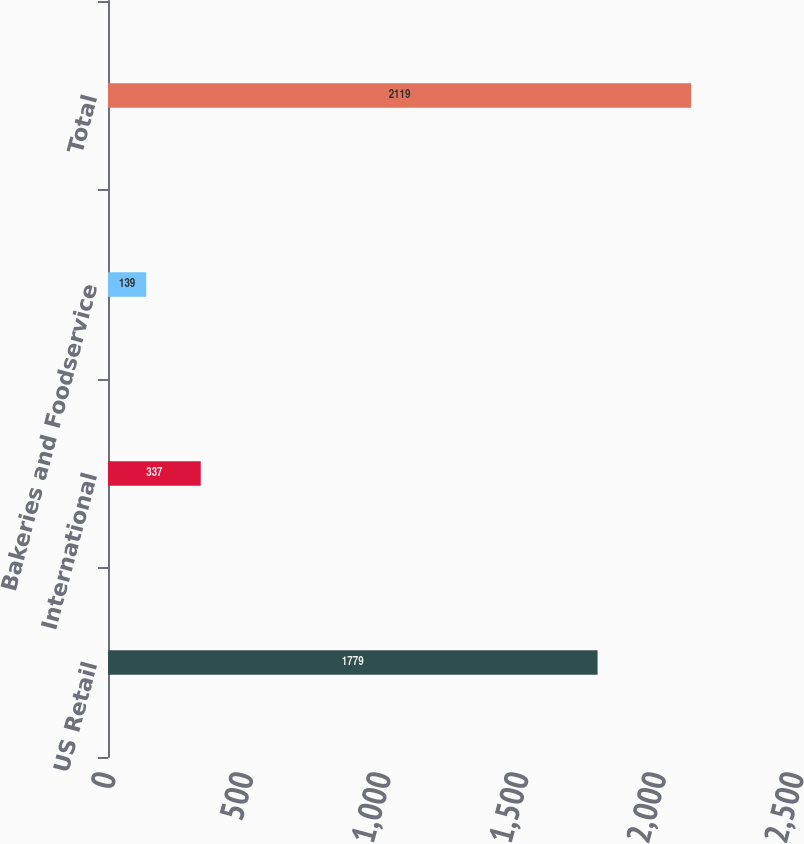Convert chart to OTSL. <chart><loc_0><loc_0><loc_500><loc_500><bar_chart><fcel>US Retail<fcel>International<fcel>Bakeries and Foodservice<fcel>Total<nl><fcel>1779<fcel>337<fcel>139<fcel>2119<nl></chart> 